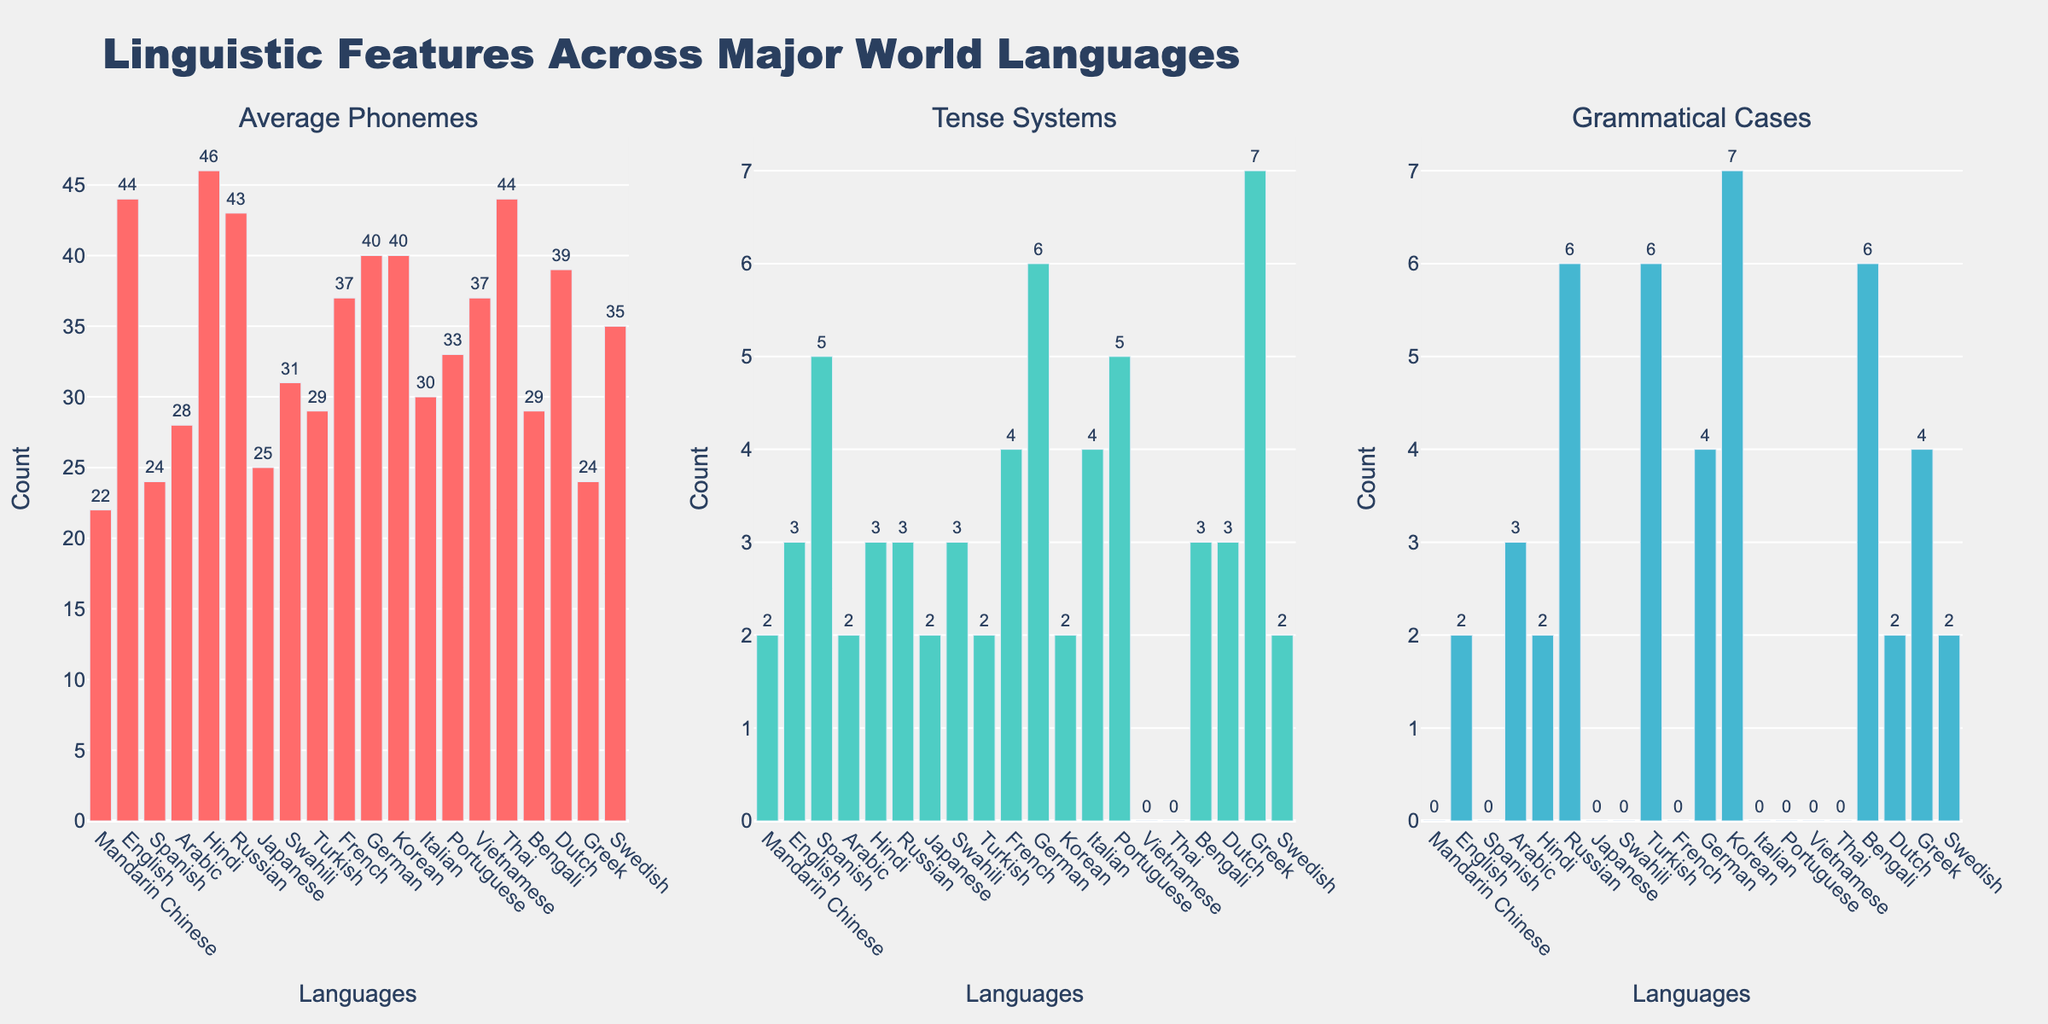Which language has the highest number of grammatical cases? To determine this, compare the height of the bars in the "Grammatical Cases" subplot. The tallest bar represents Korean with 7 grammatical cases.
Answer: Korean How many languages have more than 3 tense systems? Identify the bars in the "Tense Systems" subplot that exceed a height of 3. Count the languages represented by these bars: German (6), Greek (7), Spanish (5), Portuguese (5), and French (4), totaling 5 languages.
Answer: 5 Which language has the lowest number of average phonemes? Look at the "Average Phonemes" subplot and find the shortest bar. The shortest bar represents Mandarin Chinese with 22 phonemes.
Answer: Mandarin Chinese What is the sum of grammatical cases for Russian and Bengali? Check the heights of the bars for Russian and Bengali in the "Grammatical Cases" subplot. Russian has 6 cases, and Bengali has 6 cases. The sum is 6 + 6 = 12.
Answer: 12 Between English and Spanish, which language has more tense systems? Compare the heights of the bars for English and Spanish in the "Tense Systems" subplot. English has 3, while Spanish has 5. Spanish is higher.
Answer: Spanish Which feature has the most significant visual variation among languages? Assess all three subplots to identify which has the greatest disparity among bars. The "Grammatical Cases" subplot has the most significant variation, ranging from 0 to 7.
Answer: Grammatical Cases What is the average number of phonemes across all languages? Sum the average phonemes for all languages, which add up to 666. Divide by the number of languages (20). The average is 666 / 20 = 33.3.
Answer: 33.3 How many languages have exactly 2 tense systems? Identify the bars in the "Tense Systems" subplot that reach the height representing 2. The languages are Arabic, Mandarin Chinese, Japanese, and Korean, making a total of 4 languages.
Answer: 4 